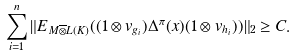Convert formula to latex. <formula><loc_0><loc_0><loc_500><loc_500>\sum ^ { n } _ { i = 1 } \| E _ { M \overline { \otimes } L ( K ) } ( ( 1 \otimes v _ { g _ { i } } ) \Delta ^ { \pi } ( x ) ( 1 \otimes v _ { h _ { i } } ) ) \| _ { 2 } \geq C .</formula> 